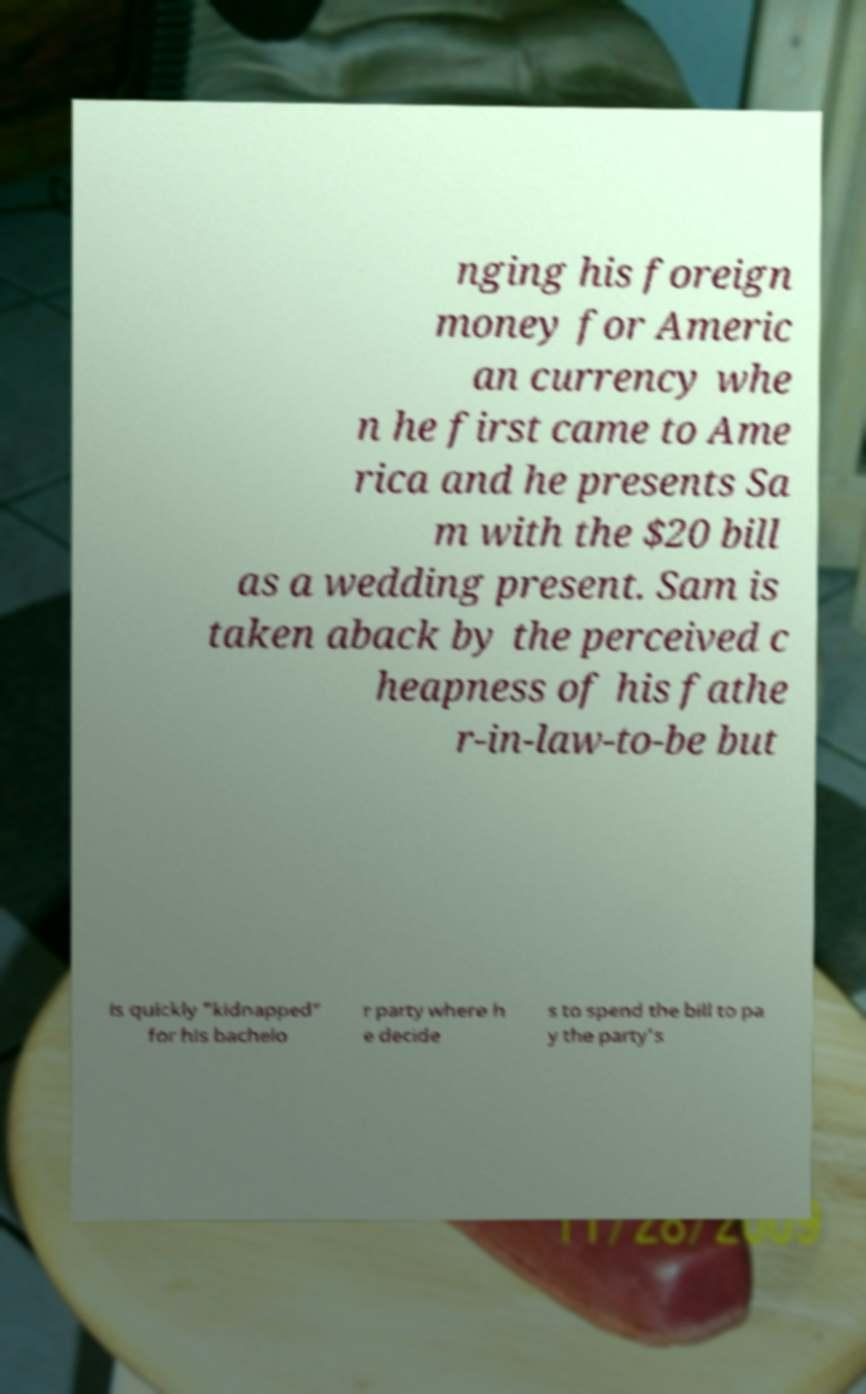Could you extract and type out the text from this image? nging his foreign money for Americ an currency whe n he first came to Ame rica and he presents Sa m with the $20 bill as a wedding present. Sam is taken aback by the perceived c heapness of his fathe r-in-law-to-be but is quickly "kidnapped" for his bachelo r party where h e decide s to spend the bill to pa y the party's 